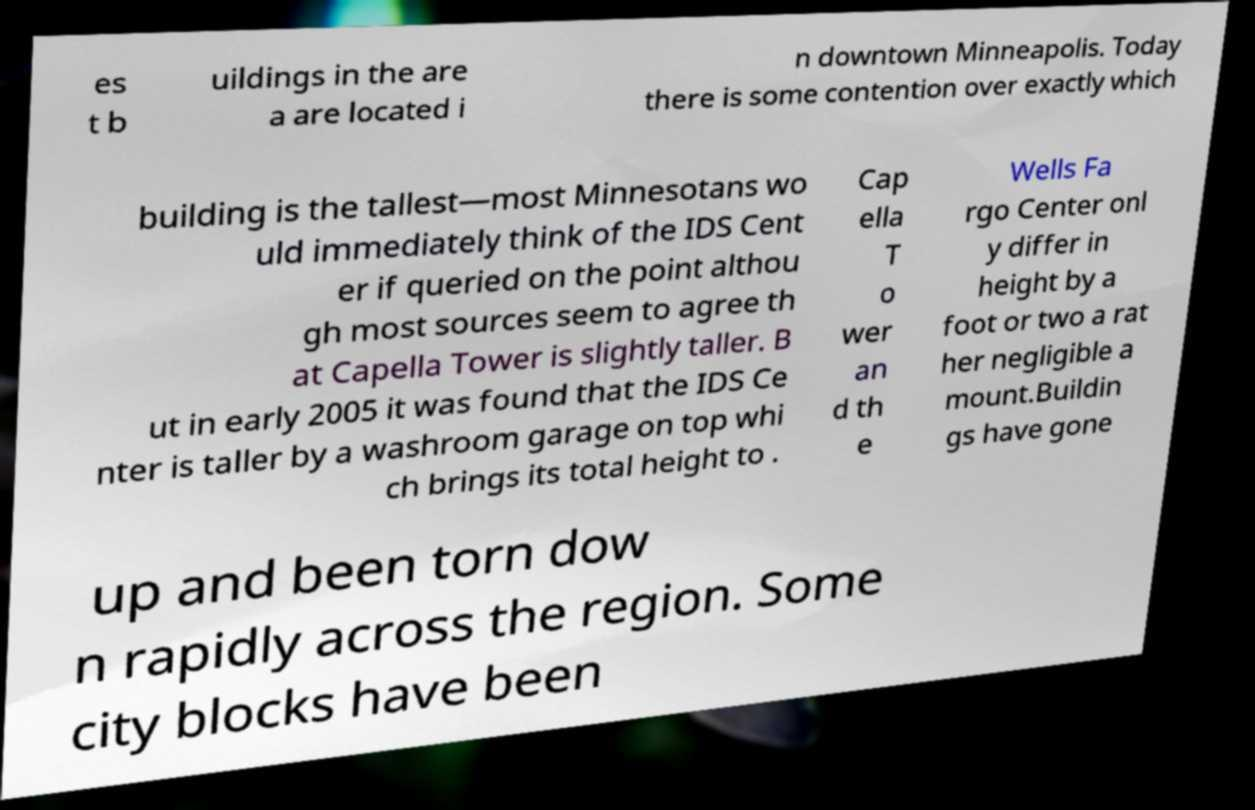Can you accurately transcribe the text from the provided image for me? es t b uildings in the are a are located i n downtown Minneapolis. Today there is some contention over exactly which building is the tallest—most Minnesotans wo uld immediately think of the IDS Cent er if queried on the point althou gh most sources seem to agree th at Capella Tower is slightly taller. B ut in early 2005 it was found that the IDS Ce nter is taller by a washroom garage on top whi ch brings its total height to . Cap ella T o wer an d th e Wells Fa rgo Center onl y differ in height by a foot or two a rat her negligible a mount.Buildin gs have gone up and been torn dow n rapidly across the region. Some city blocks have been 